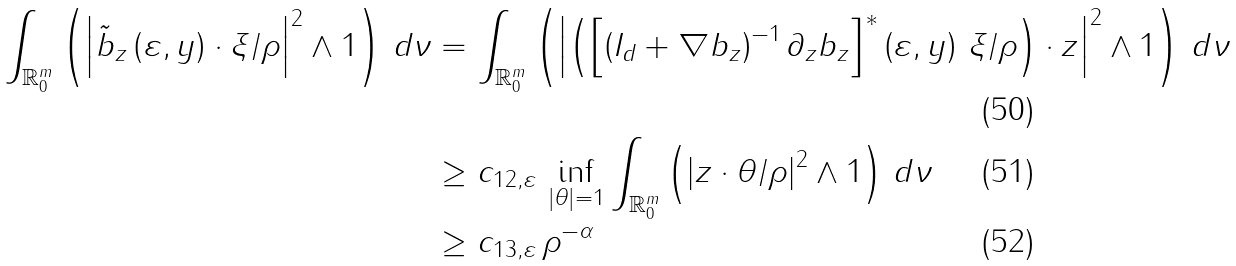Convert formula to latex. <formula><loc_0><loc_0><loc_500><loc_500>\int _ { \mathbb { R } _ { 0 } ^ { m } } \left ( \left | \tilde { b } _ { z } \left ( \varepsilon , y \right ) \cdot \xi / \rho \right | ^ { 2 } \wedge 1 \right ) \, d \nu & = \int _ { \mathbb { R } _ { 0 } ^ { m } } \left ( \left | \left ( \left [ \left ( I _ { d } + \nabla b _ { z } \right ) ^ { - 1 } \partial _ { z } b _ { z } \right ] ^ { \ast } \left ( \varepsilon , y \right ) \, \xi / \rho \right ) \cdot z \right | ^ { 2 } \wedge 1 \right ) \, d \nu \\ & \geq c _ { 1 2 , \varepsilon } \, \inf _ { \left | \theta \right | = 1 } \int _ { \mathbb { R } _ { 0 } ^ { m } } \left ( \left | z \cdot \theta / \rho \right | ^ { 2 } \wedge 1 \right ) \, d \nu \\ & \geq c _ { 1 3 , \varepsilon } \, \rho ^ { - \alpha }</formula> 